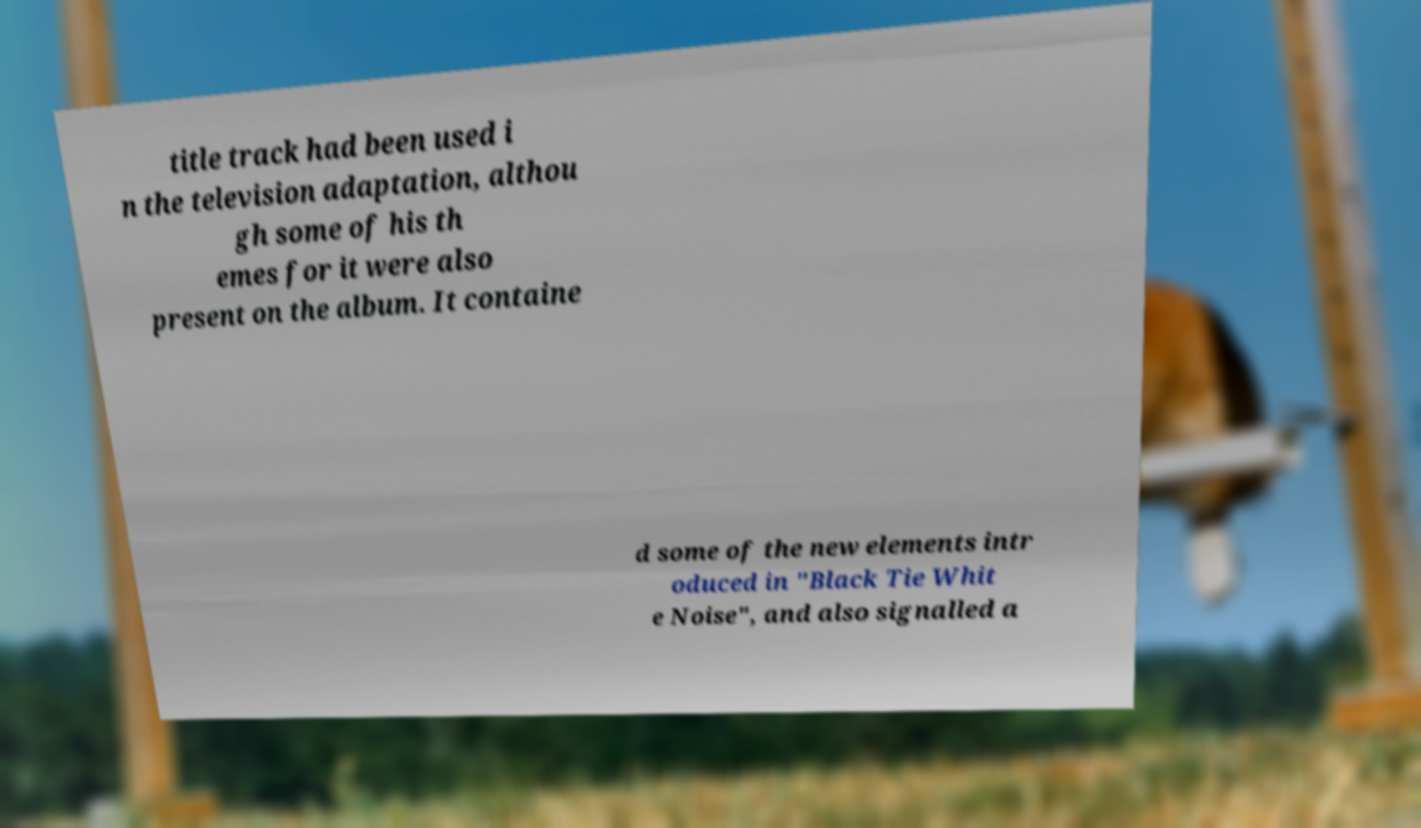Could you assist in decoding the text presented in this image and type it out clearly? title track had been used i n the television adaptation, althou gh some of his th emes for it were also present on the album. It containe d some of the new elements intr oduced in "Black Tie Whit e Noise", and also signalled a 